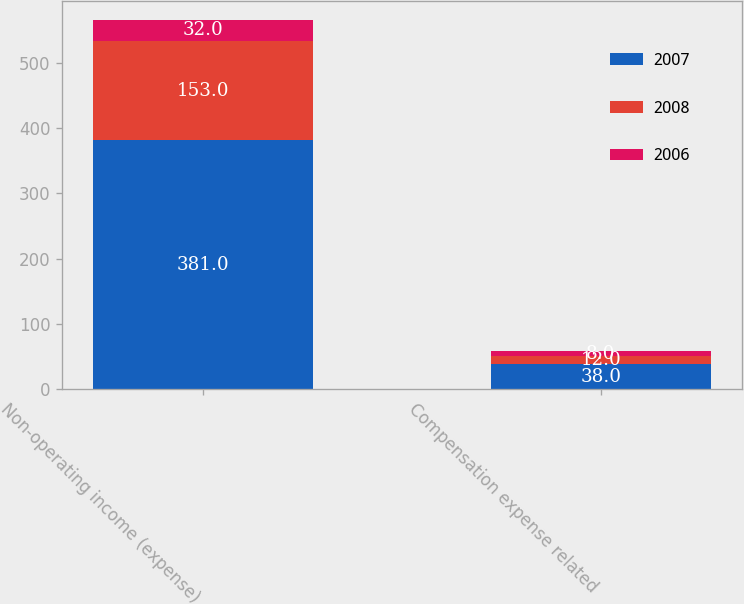Convert chart to OTSL. <chart><loc_0><loc_0><loc_500><loc_500><stacked_bar_chart><ecel><fcel>Non-operating income (expense)<fcel>Compensation expense related<nl><fcel>2007<fcel>381<fcel>38<nl><fcel>2008<fcel>153<fcel>12<nl><fcel>2006<fcel>32<fcel>8<nl></chart> 